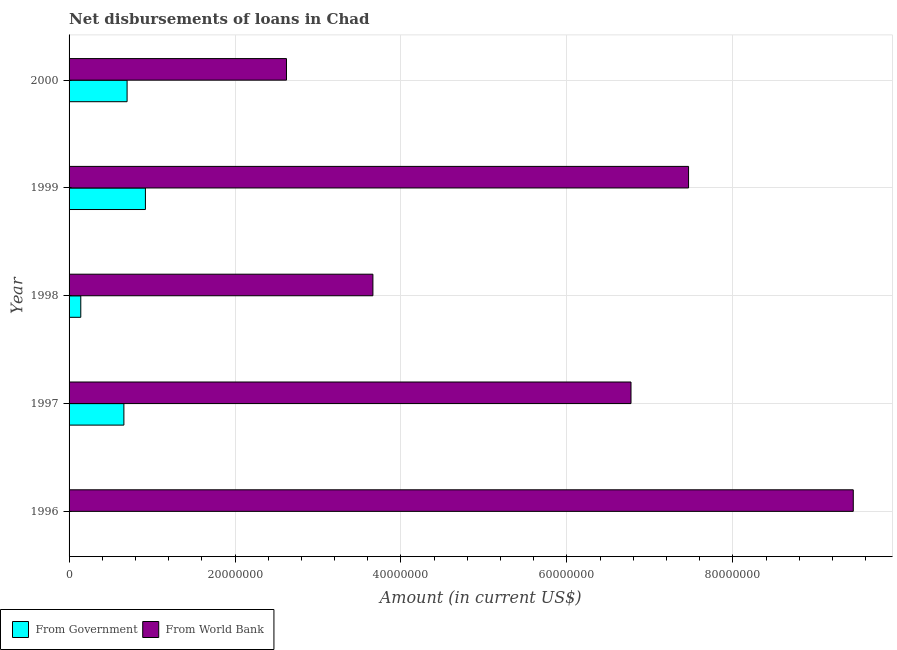Are the number of bars on each tick of the Y-axis equal?
Offer a very short reply. No. How many bars are there on the 2nd tick from the top?
Give a very brief answer. 2. What is the label of the 4th group of bars from the top?
Give a very brief answer. 1997. Across all years, what is the maximum net disbursements of loan from world bank?
Offer a very short reply. 9.45e+07. Across all years, what is the minimum net disbursements of loan from government?
Provide a short and direct response. 0. In which year was the net disbursements of loan from government maximum?
Make the answer very short. 1999. What is the total net disbursements of loan from government in the graph?
Provide a short and direct response. 2.42e+07. What is the difference between the net disbursements of loan from government in 1998 and that in 2000?
Make the answer very short. -5.58e+06. What is the difference between the net disbursements of loan from government in 2000 and the net disbursements of loan from world bank in 1998?
Your answer should be compact. -2.96e+07. What is the average net disbursements of loan from world bank per year?
Your response must be concise. 5.99e+07. In the year 1997, what is the difference between the net disbursements of loan from world bank and net disbursements of loan from government?
Your response must be concise. 6.11e+07. What is the ratio of the net disbursements of loan from world bank in 1996 to that in 1998?
Make the answer very short. 2.58. What is the difference between the highest and the second highest net disbursements of loan from government?
Your answer should be compact. 2.21e+06. What is the difference between the highest and the lowest net disbursements of loan from world bank?
Offer a very short reply. 6.83e+07. How many bars are there?
Your response must be concise. 9. Are all the bars in the graph horizontal?
Your response must be concise. Yes. What is the difference between two consecutive major ticks on the X-axis?
Your answer should be compact. 2.00e+07. Does the graph contain grids?
Your answer should be compact. Yes. Where does the legend appear in the graph?
Your response must be concise. Bottom left. How many legend labels are there?
Offer a terse response. 2. How are the legend labels stacked?
Offer a terse response. Horizontal. What is the title of the graph?
Offer a terse response. Net disbursements of loans in Chad. Does "All education staff compensation" appear as one of the legend labels in the graph?
Your answer should be compact. No. What is the label or title of the X-axis?
Your answer should be very brief. Amount (in current US$). What is the label or title of the Y-axis?
Offer a terse response. Year. What is the Amount (in current US$) of From Government in 1996?
Provide a succinct answer. 0. What is the Amount (in current US$) in From World Bank in 1996?
Your response must be concise. 9.45e+07. What is the Amount (in current US$) in From Government in 1997?
Keep it short and to the point. 6.61e+06. What is the Amount (in current US$) of From World Bank in 1997?
Make the answer very short. 6.77e+07. What is the Amount (in current US$) in From Government in 1998?
Your answer should be compact. 1.41e+06. What is the Amount (in current US$) of From World Bank in 1998?
Ensure brevity in your answer.  3.66e+07. What is the Amount (in current US$) in From Government in 1999?
Provide a short and direct response. 9.20e+06. What is the Amount (in current US$) in From World Bank in 1999?
Make the answer very short. 7.47e+07. What is the Amount (in current US$) of From Government in 2000?
Keep it short and to the point. 6.99e+06. What is the Amount (in current US$) of From World Bank in 2000?
Make the answer very short. 2.62e+07. Across all years, what is the maximum Amount (in current US$) in From Government?
Make the answer very short. 9.20e+06. Across all years, what is the maximum Amount (in current US$) in From World Bank?
Your answer should be compact. 9.45e+07. Across all years, what is the minimum Amount (in current US$) of From World Bank?
Offer a terse response. 2.62e+07. What is the total Amount (in current US$) of From Government in the graph?
Your response must be concise. 2.42e+07. What is the total Amount (in current US$) in From World Bank in the graph?
Your response must be concise. 3.00e+08. What is the difference between the Amount (in current US$) in From World Bank in 1996 and that in 1997?
Offer a terse response. 2.68e+07. What is the difference between the Amount (in current US$) of From World Bank in 1996 and that in 1998?
Ensure brevity in your answer.  5.79e+07. What is the difference between the Amount (in current US$) of From World Bank in 1996 and that in 1999?
Offer a terse response. 1.99e+07. What is the difference between the Amount (in current US$) of From World Bank in 1996 and that in 2000?
Offer a terse response. 6.83e+07. What is the difference between the Amount (in current US$) of From Government in 1997 and that in 1998?
Your answer should be compact. 5.20e+06. What is the difference between the Amount (in current US$) of From World Bank in 1997 and that in 1998?
Provide a succinct answer. 3.11e+07. What is the difference between the Amount (in current US$) of From Government in 1997 and that in 1999?
Provide a succinct answer. -2.59e+06. What is the difference between the Amount (in current US$) of From World Bank in 1997 and that in 1999?
Provide a succinct answer. -6.94e+06. What is the difference between the Amount (in current US$) in From Government in 1997 and that in 2000?
Your response must be concise. -3.85e+05. What is the difference between the Amount (in current US$) in From World Bank in 1997 and that in 2000?
Offer a very short reply. 4.15e+07. What is the difference between the Amount (in current US$) of From Government in 1998 and that in 1999?
Your answer should be very brief. -7.79e+06. What is the difference between the Amount (in current US$) in From World Bank in 1998 and that in 1999?
Provide a short and direct response. -3.80e+07. What is the difference between the Amount (in current US$) in From Government in 1998 and that in 2000?
Provide a short and direct response. -5.58e+06. What is the difference between the Amount (in current US$) of From World Bank in 1998 and that in 2000?
Your answer should be compact. 1.04e+07. What is the difference between the Amount (in current US$) in From Government in 1999 and that in 2000?
Your response must be concise. 2.21e+06. What is the difference between the Amount (in current US$) in From World Bank in 1999 and that in 2000?
Provide a short and direct response. 4.85e+07. What is the difference between the Amount (in current US$) in From Government in 1997 and the Amount (in current US$) in From World Bank in 1998?
Your answer should be very brief. -3.00e+07. What is the difference between the Amount (in current US$) of From Government in 1997 and the Amount (in current US$) of From World Bank in 1999?
Your answer should be very brief. -6.81e+07. What is the difference between the Amount (in current US$) in From Government in 1997 and the Amount (in current US$) in From World Bank in 2000?
Your answer should be very brief. -1.96e+07. What is the difference between the Amount (in current US$) of From Government in 1998 and the Amount (in current US$) of From World Bank in 1999?
Provide a succinct answer. -7.33e+07. What is the difference between the Amount (in current US$) of From Government in 1998 and the Amount (in current US$) of From World Bank in 2000?
Give a very brief answer. -2.48e+07. What is the difference between the Amount (in current US$) in From Government in 1999 and the Amount (in current US$) in From World Bank in 2000?
Provide a short and direct response. -1.70e+07. What is the average Amount (in current US$) in From Government per year?
Offer a very short reply. 4.84e+06. What is the average Amount (in current US$) of From World Bank per year?
Provide a short and direct response. 5.99e+07. In the year 1997, what is the difference between the Amount (in current US$) of From Government and Amount (in current US$) of From World Bank?
Offer a terse response. -6.11e+07. In the year 1998, what is the difference between the Amount (in current US$) in From Government and Amount (in current US$) in From World Bank?
Ensure brevity in your answer.  -3.52e+07. In the year 1999, what is the difference between the Amount (in current US$) in From Government and Amount (in current US$) in From World Bank?
Provide a short and direct response. -6.55e+07. In the year 2000, what is the difference between the Amount (in current US$) in From Government and Amount (in current US$) in From World Bank?
Offer a very short reply. -1.92e+07. What is the ratio of the Amount (in current US$) of From World Bank in 1996 to that in 1997?
Provide a short and direct response. 1.4. What is the ratio of the Amount (in current US$) in From World Bank in 1996 to that in 1998?
Your answer should be compact. 2.58. What is the ratio of the Amount (in current US$) of From World Bank in 1996 to that in 1999?
Ensure brevity in your answer.  1.27. What is the ratio of the Amount (in current US$) of From World Bank in 1996 to that in 2000?
Provide a short and direct response. 3.61. What is the ratio of the Amount (in current US$) in From Government in 1997 to that in 1998?
Make the answer very short. 4.68. What is the ratio of the Amount (in current US$) in From World Bank in 1997 to that in 1998?
Your answer should be compact. 1.85. What is the ratio of the Amount (in current US$) in From Government in 1997 to that in 1999?
Offer a very short reply. 0.72. What is the ratio of the Amount (in current US$) in From World Bank in 1997 to that in 1999?
Keep it short and to the point. 0.91. What is the ratio of the Amount (in current US$) in From Government in 1997 to that in 2000?
Your answer should be compact. 0.94. What is the ratio of the Amount (in current US$) of From World Bank in 1997 to that in 2000?
Your response must be concise. 2.58. What is the ratio of the Amount (in current US$) in From Government in 1998 to that in 1999?
Your answer should be compact. 0.15. What is the ratio of the Amount (in current US$) in From World Bank in 1998 to that in 1999?
Your response must be concise. 0.49. What is the ratio of the Amount (in current US$) in From Government in 1998 to that in 2000?
Ensure brevity in your answer.  0.2. What is the ratio of the Amount (in current US$) in From World Bank in 1998 to that in 2000?
Offer a very short reply. 1.4. What is the ratio of the Amount (in current US$) in From Government in 1999 to that in 2000?
Provide a short and direct response. 1.32. What is the ratio of the Amount (in current US$) in From World Bank in 1999 to that in 2000?
Offer a very short reply. 2.85. What is the difference between the highest and the second highest Amount (in current US$) in From Government?
Provide a succinct answer. 2.21e+06. What is the difference between the highest and the second highest Amount (in current US$) in From World Bank?
Ensure brevity in your answer.  1.99e+07. What is the difference between the highest and the lowest Amount (in current US$) of From Government?
Your answer should be very brief. 9.20e+06. What is the difference between the highest and the lowest Amount (in current US$) of From World Bank?
Keep it short and to the point. 6.83e+07. 